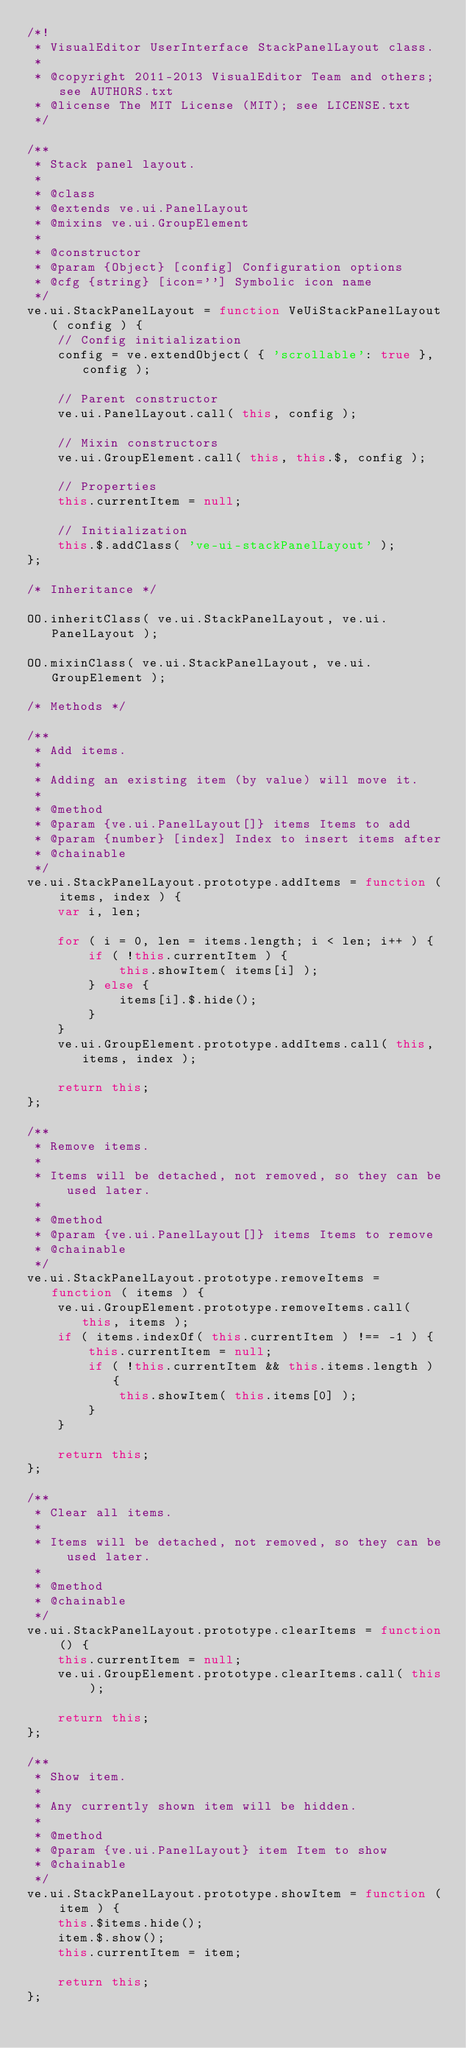<code> <loc_0><loc_0><loc_500><loc_500><_JavaScript_>/*!
 * VisualEditor UserInterface StackPanelLayout class.
 *
 * @copyright 2011-2013 VisualEditor Team and others; see AUTHORS.txt
 * @license The MIT License (MIT); see LICENSE.txt
 */

/**
 * Stack panel layout.
 *
 * @class
 * @extends ve.ui.PanelLayout
 * @mixins ve.ui.GroupElement
 *
 * @constructor
 * @param {Object} [config] Configuration options
 * @cfg {string} [icon=''] Symbolic icon name
 */
ve.ui.StackPanelLayout = function VeUiStackPanelLayout( config ) {
	// Config initialization
	config = ve.extendObject( { 'scrollable': true }, config );

	// Parent constructor
	ve.ui.PanelLayout.call( this, config );

	// Mixin constructors
	ve.ui.GroupElement.call( this, this.$, config );

	// Properties
	this.currentItem = null;

	// Initialization
	this.$.addClass( 've-ui-stackPanelLayout' );
};

/* Inheritance */

OO.inheritClass( ve.ui.StackPanelLayout, ve.ui.PanelLayout );

OO.mixinClass( ve.ui.StackPanelLayout, ve.ui.GroupElement );

/* Methods */

/**
 * Add items.
 *
 * Adding an existing item (by value) will move it.
 *
 * @method
 * @param {ve.ui.PanelLayout[]} items Items to add
 * @param {number} [index] Index to insert items after
 * @chainable
 */
ve.ui.StackPanelLayout.prototype.addItems = function ( items, index ) {
	var i, len;

	for ( i = 0, len = items.length; i < len; i++ ) {
		if ( !this.currentItem ) {
			this.showItem( items[i] );
		} else {
			items[i].$.hide();
		}
	}
	ve.ui.GroupElement.prototype.addItems.call( this, items, index );

	return this;
};

/**
 * Remove items.
 *
 * Items will be detached, not removed, so they can be used later.
 *
 * @method
 * @param {ve.ui.PanelLayout[]} items Items to remove
 * @chainable
 */
ve.ui.StackPanelLayout.prototype.removeItems = function ( items ) {
	ve.ui.GroupElement.prototype.removeItems.call( this, items );
	if ( items.indexOf( this.currentItem ) !== -1 ) {
		this.currentItem = null;
		if ( !this.currentItem && this.items.length ) {
			this.showItem( this.items[0] );
		}
	}

	return this;
};

/**
 * Clear all items.
 *
 * Items will be detached, not removed, so they can be used later.
 *
 * @method
 * @chainable
 */
ve.ui.StackPanelLayout.prototype.clearItems = function () {
	this.currentItem = null;
	ve.ui.GroupElement.prototype.clearItems.call( this );

	return this;
};

/**
 * Show item.
 *
 * Any currently shown item will be hidden.
 *
 * @method
 * @param {ve.ui.PanelLayout} item Item to show
 * @chainable
 */
ve.ui.StackPanelLayout.prototype.showItem = function ( item ) {
	this.$items.hide();
	item.$.show();
	this.currentItem = item;

	return this;
};
</code> 